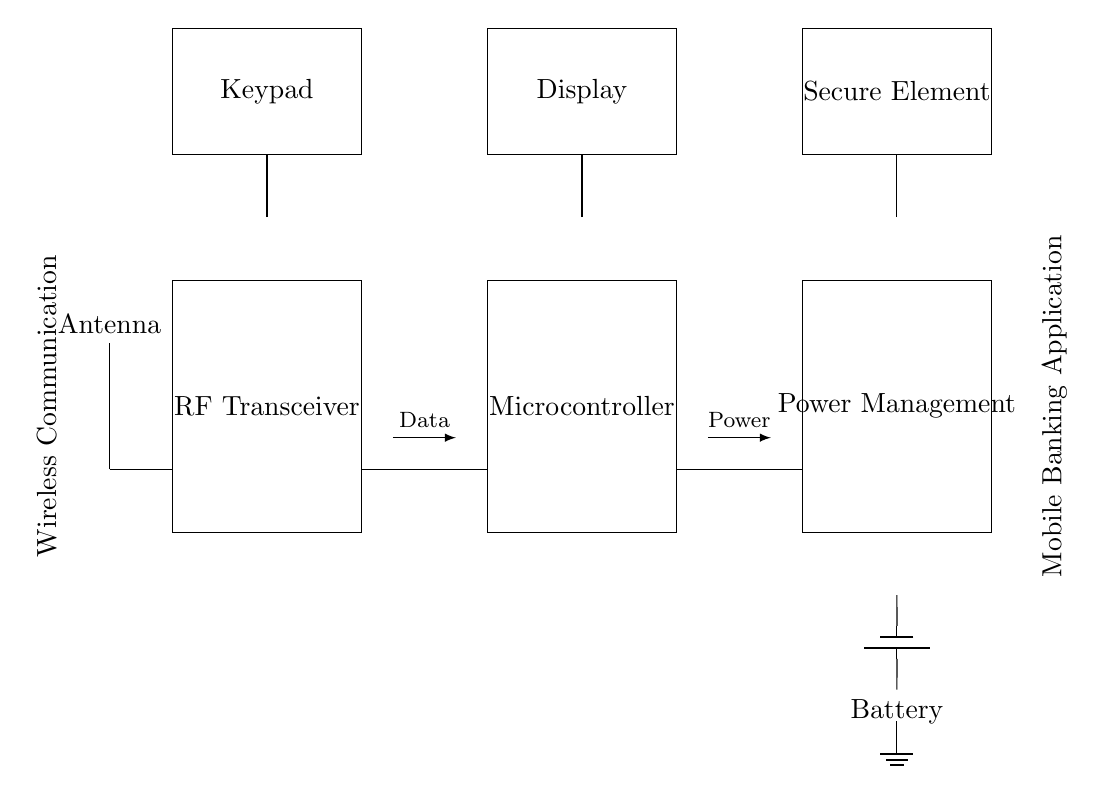What is the main component for wireless communication? The main component for wireless communication in the circuit is the antenna, which is essential for transmitting and receiving radio frequency signals.
Answer: Antenna What does the RF transceiver do? The RF transceiver is responsible for both transmitting and receiving data wirelessly, facilitating communication between devices.
Answer: Transmits and receives data How many connections are there from the antenna to the RF transceiver? There is one direct connection from the antenna to the RF transceiver, as shown in the diagram, where the antenna is linked directly to the RF transceiver.
Answer: One What is the purpose of the secure element? The secure element ensures the security of sensitive data, such as encryption keys and user information, which is especially important in mobile banking applications.
Answer: Security Which component provides power to the circuit? The battery is responsible for providing power to the circuit, supplying the necessary energy for all components to function.
Answer: Battery What type of application is this circuit designed for? This circuit is designed for mobile banking applications, enabling transactions and remote loan processing.
Answer: Mobile banking What is the relationship between the microcontroller and the display? The microcontroller processes data and sends it to the display for the user interface, allowing interactions and visual feedback in the mobile banking application.
Answer: Data processing 